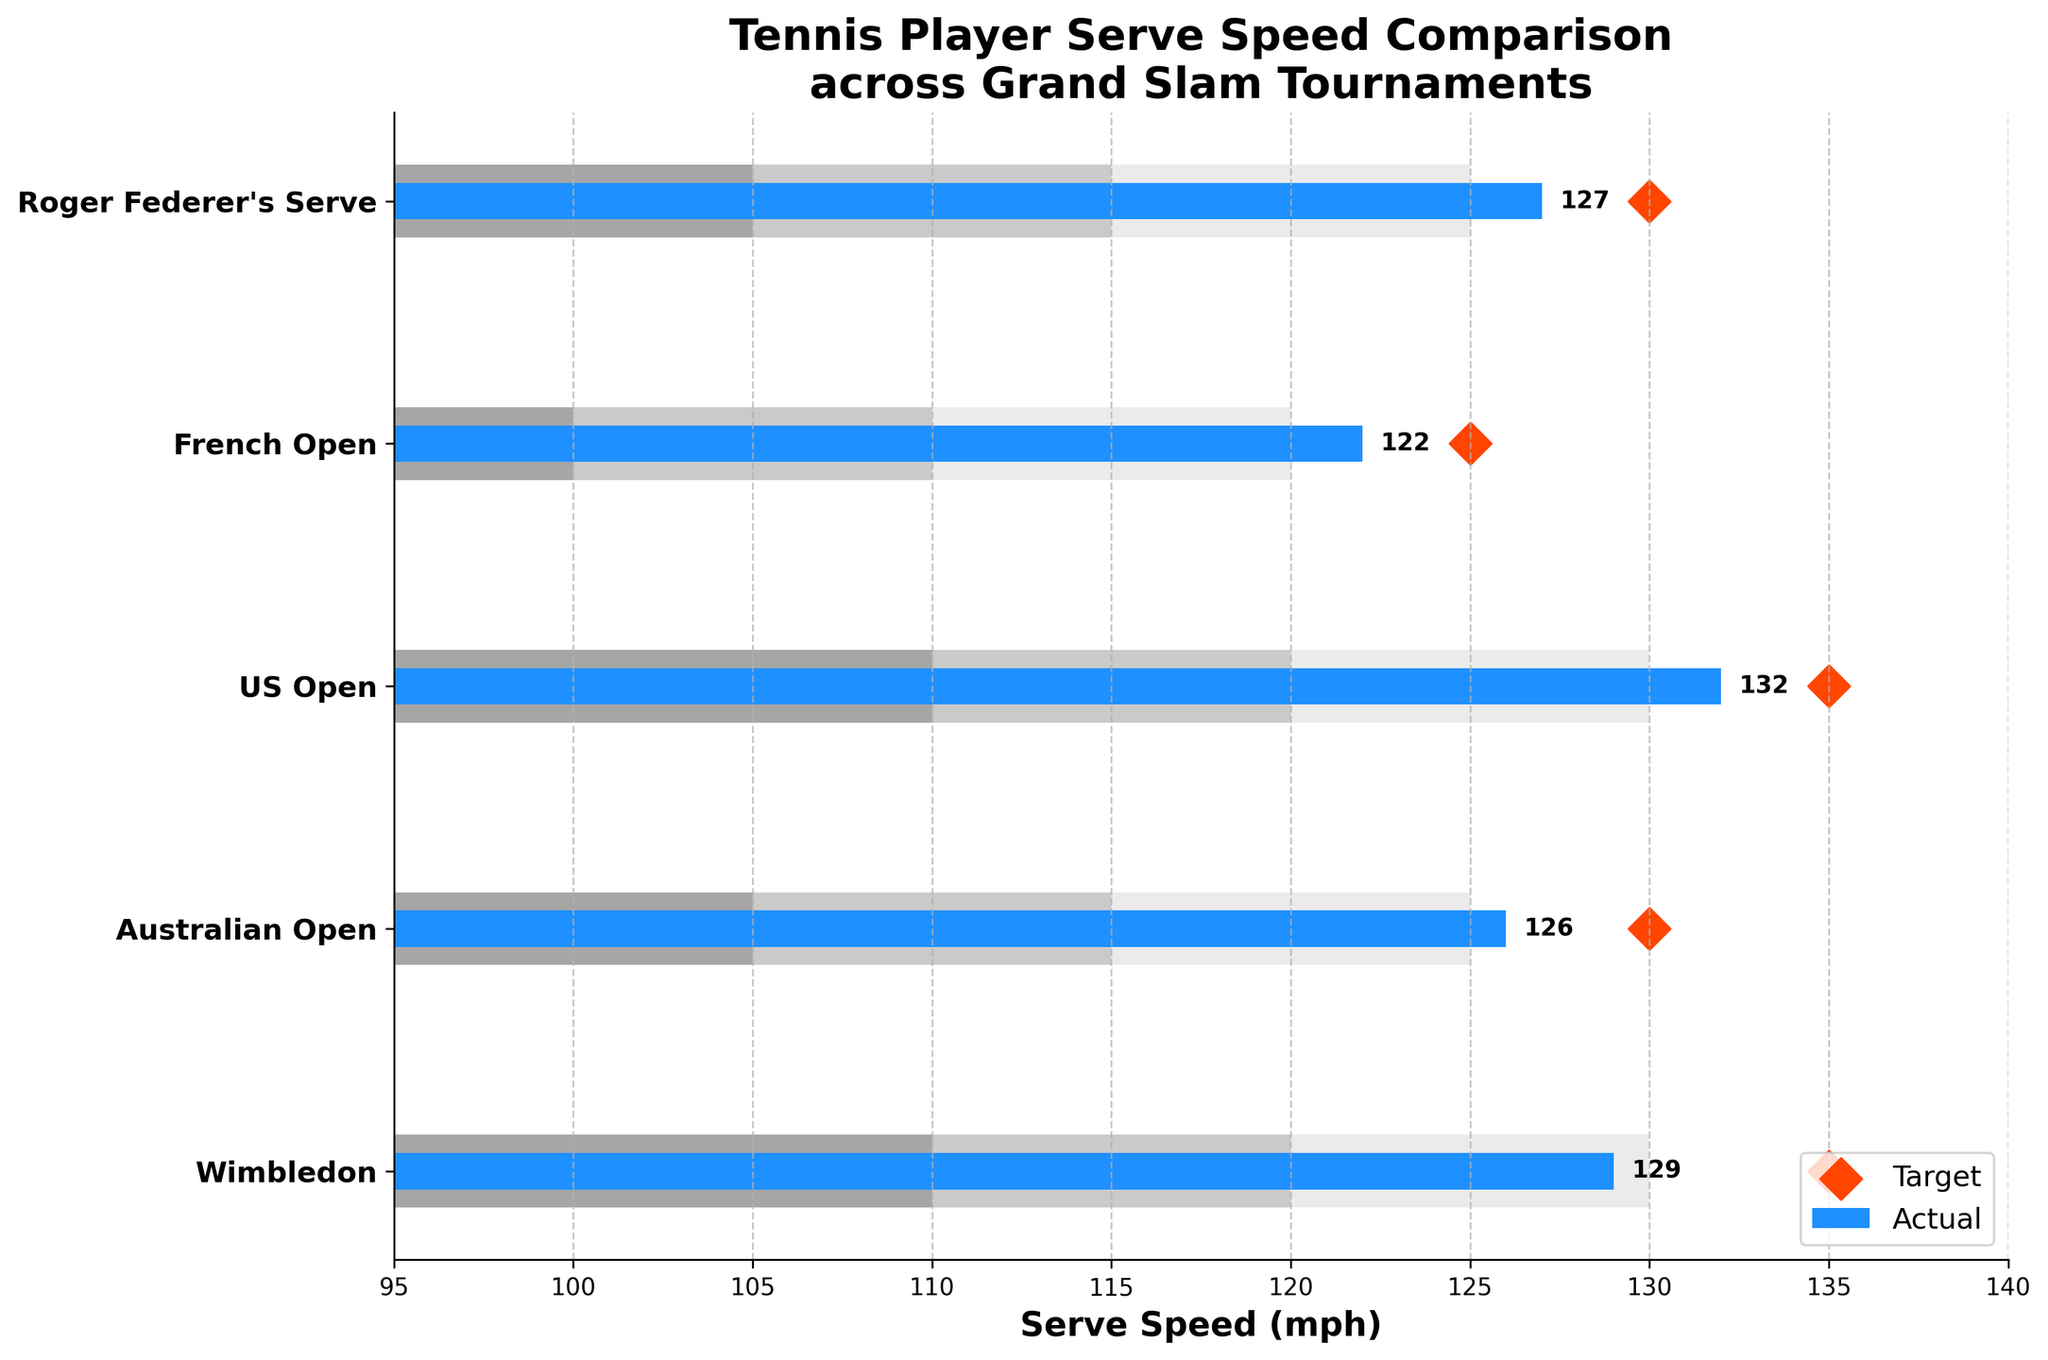What is the title of the chart? The title can be found at the top of the chart. It is 'Tennis Player Serve Speed Comparison across Grand Slam Tournaments.'
Answer: Tennis Player Serve Speed Comparison across Grand Slam Tournaments How many tournaments are compared in this chart? By counting the number of items on the y-axis, we see that there are five items: Wimbledon, Australian Open, US Open, French Open, and Roger Federer's Serve.
Answer: 5 What is the serve speed for the US Open? By looking at the bar for the US Open, the actual serve speed is labeled on the bar, which is 132 mph.
Answer: 132 mph What is the target serve speed for Wimbledon? The target is indicated by a diamond marker ('D') on the chart. For Wimbledon, the diamond is at 135 mph.
Answer: 135 mph What is Roger Federer's serve speed in comparison to the target at the Australian Open? Roger Federer's serve speed is shown to be 127 mph. The target for the Australian Open is 130 mph. Comparing the two: 127 mph - 130 mph = -3 mph.
Answer: 3 mph slower Which tournament has the highest actual serve speed? By examining the length of the bars, the longest bar is for the US Open, which has an actual serve speed of 132 mph.
Answer: US Open For the French Open, is the actual serve speed within the acceptable range? The actual serve speed for the French Open is 122 mph. The acceptable range (up to Range3) is 100-120 mph. 122 mph is slightly above the highest range.
Answer: No How much higher is the actual serve speed at the US Open compared to Wimbledon? The actual serve speed for the US Open is 132 mph, and for Wimbledon, it is 129 mph. So, 132 mph - 129 mph = 3 mph.
Answer: 3 mph Which Grand Slam's actual serve speed falls within its second acceptable range of 115-125 mph? Examining the data, the Australian Open's actual serve speed is 126 mph, and Roger Federer's serve speed is 127 mph. The second acceptable range for Roger Federer is 115-125 mph; so none fall within this range.
Answer: None 